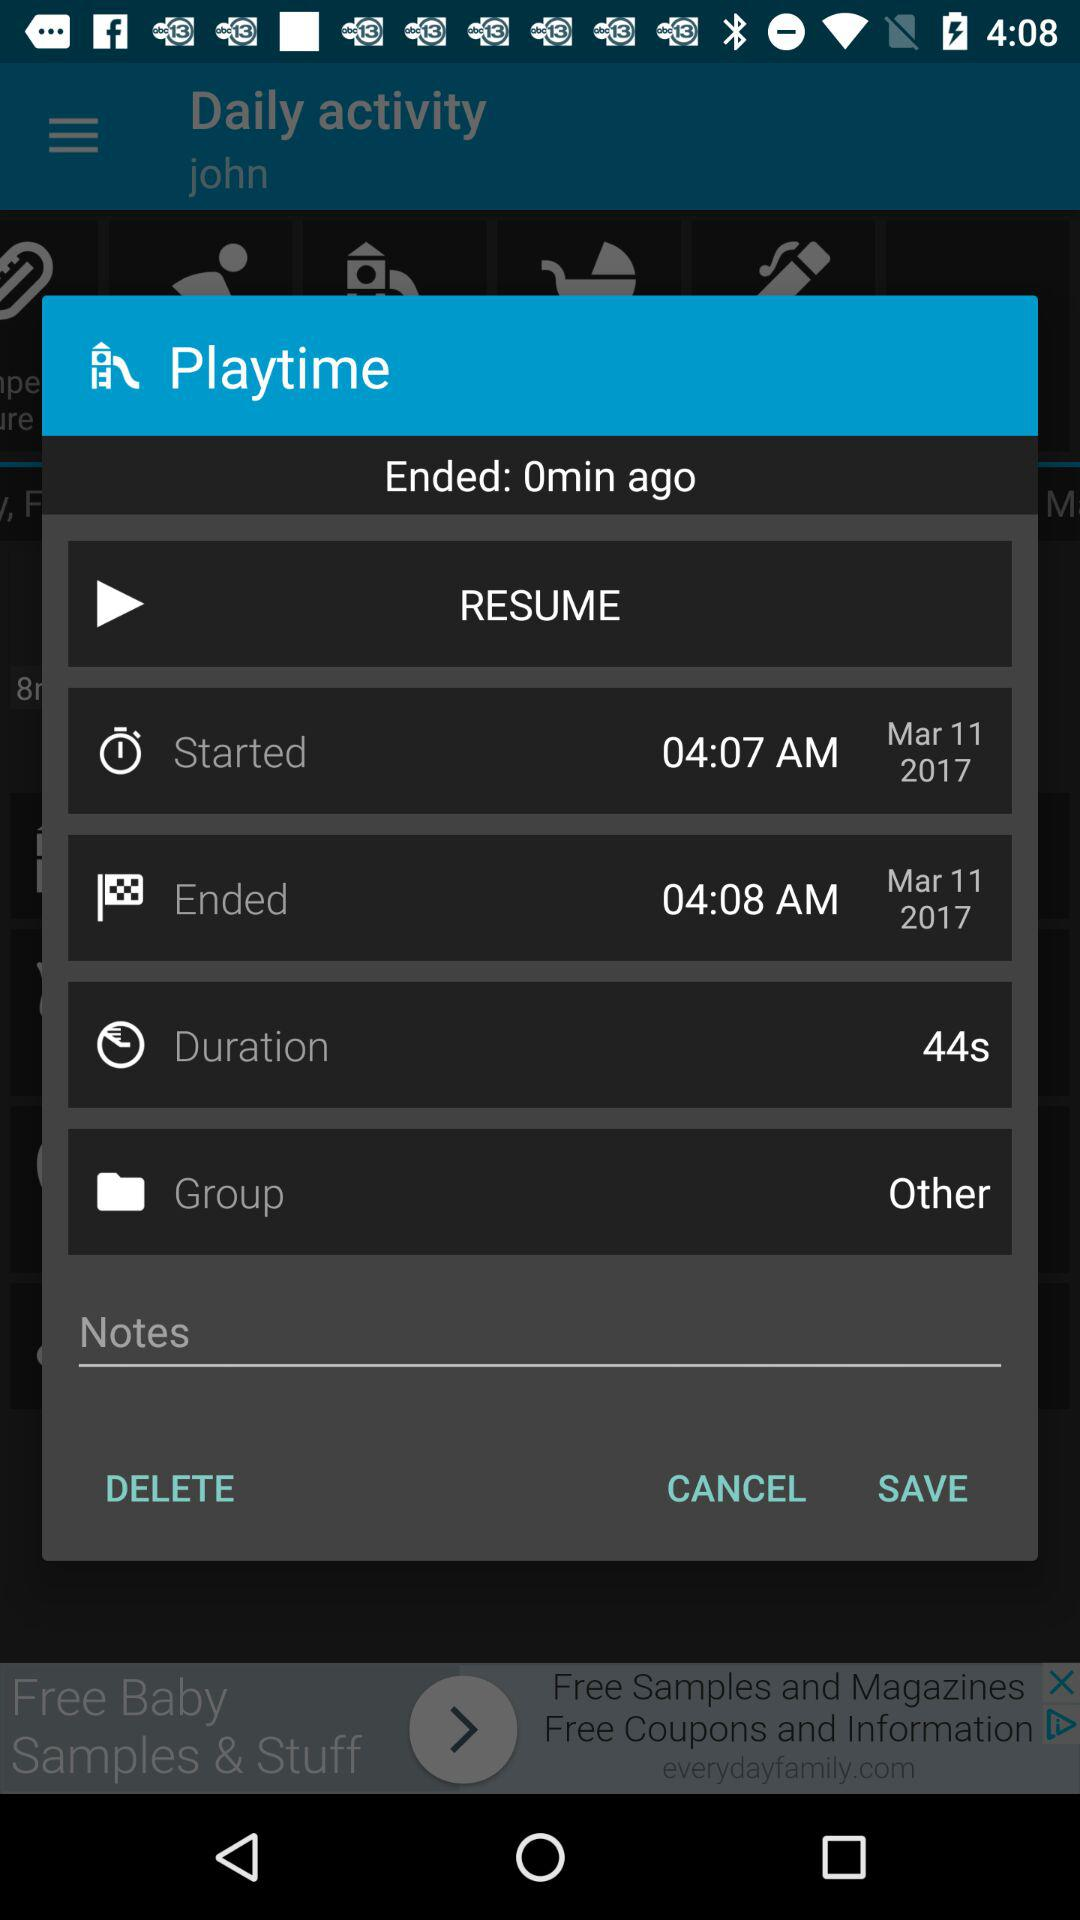What is the time duration? The time duration is 44 seconds. 